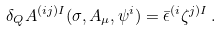<formula> <loc_0><loc_0><loc_500><loc_500>\delta _ { Q } A ^ { ( i j ) I } ( \sigma , A _ { \mu } , \psi ^ { i } ) = \bar { \epsilon } ^ { ( i } \zeta ^ { j ) I } \, .</formula> 